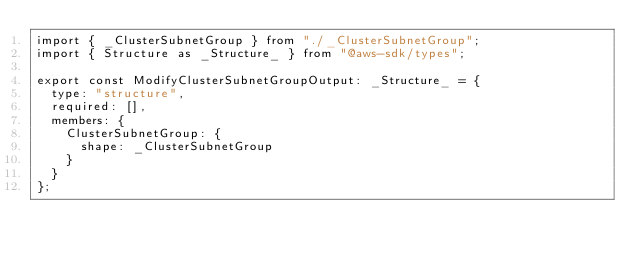Convert code to text. <code><loc_0><loc_0><loc_500><loc_500><_TypeScript_>import { _ClusterSubnetGroup } from "./_ClusterSubnetGroup";
import { Structure as _Structure_ } from "@aws-sdk/types";

export const ModifyClusterSubnetGroupOutput: _Structure_ = {
  type: "structure",
  required: [],
  members: {
    ClusterSubnetGroup: {
      shape: _ClusterSubnetGroup
    }
  }
};
</code> 